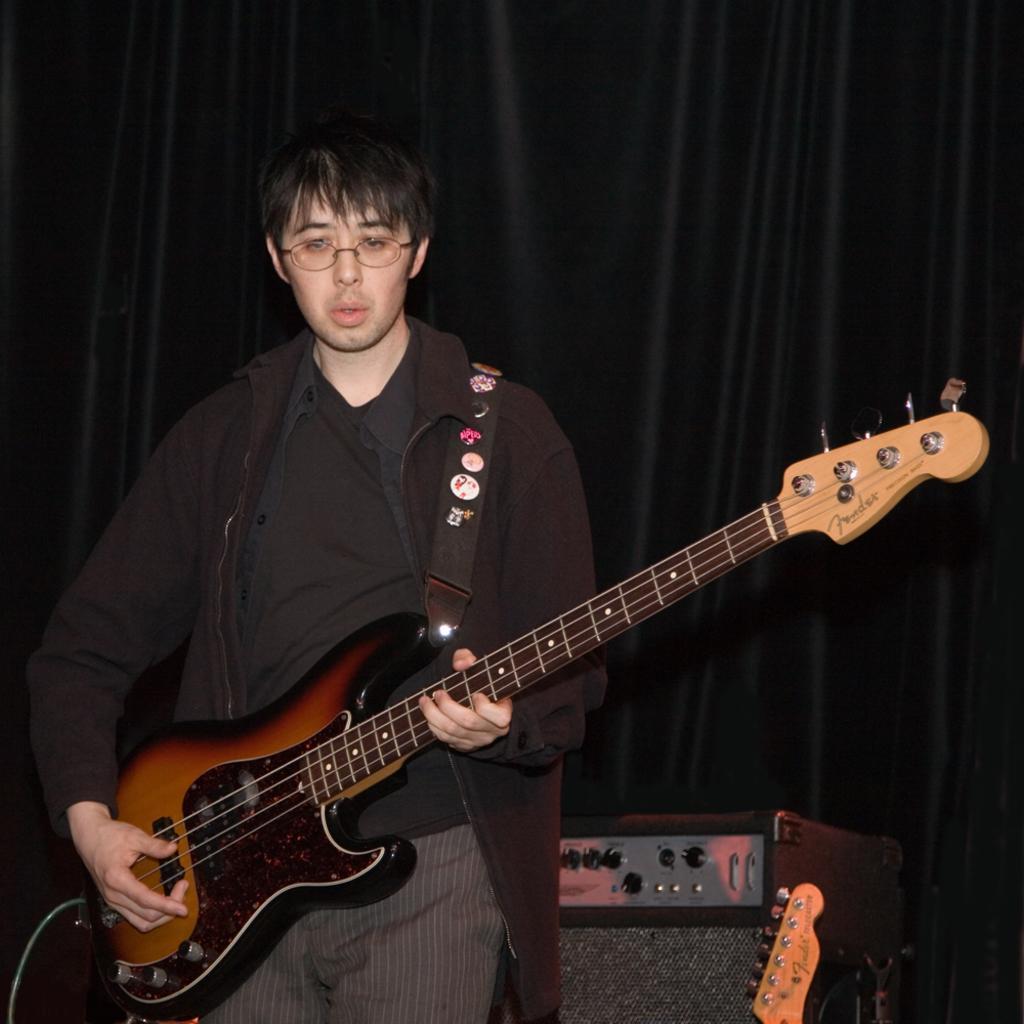Please provide a concise description of this image. In this image we can see a person holding a guitar in his hand is standing. On the right side of the image we can see a speaker and a musical instrument. At the top of the image we can see the curtains. 